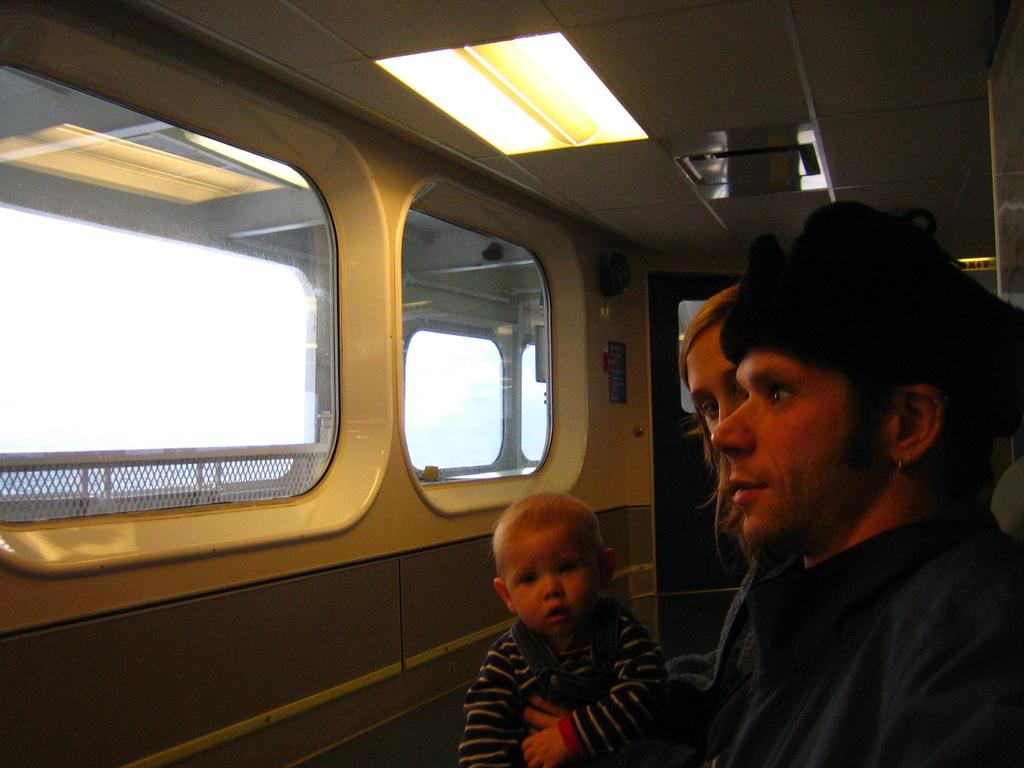How many people are in the vehicle in the image? There are three persons in the vehicle. What is located at the top of the image? There are lights visible at the top of the image. What can be seen through the windows of the vehicle? The sky is visible through the windows of the vehicle. What type of pies can be seen on the seashore in the image? There is no seashore or pies present in the image; it features a vehicle with three persons inside. 